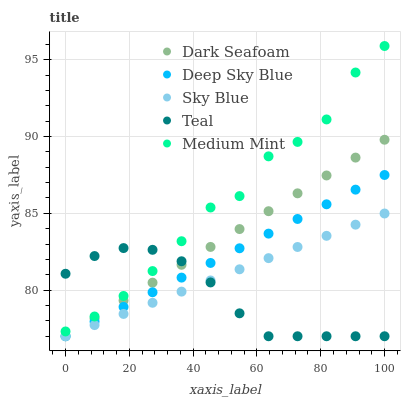Does Teal have the minimum area under the curve?
Answer yes or no. Yes. Does Medium Mint have the maximum area under the curve?
Answer yes or no. Yes. Does Sky Blue have the minimum area under the curve?
Answer yes or no. No. Does Sky Blue have the maximum area under the curve?
Answer yes or no. No. Is Deep Sky Blue the smoothest?
Answer yes or no. Yes. Is Medium Mint the roughest?
Answer yes or no. Yes. Is Sky Blue the smoothest?
Answer yes or no. No. Is Sky Blue the roughest?
Answer yes or no. No. Does Sky Blue have the lowest value?
Answer yes or no. Yes. Does Medium Mint have the highest value?
Answer yes or no. Yes. Does Sky Blue have the highest value?
Answer yes or no. No. Is Dark Seafoam less than Medium Mint?
Answer yes or no. Yes. Is Medium Mint greater than Dark Seafoam?
Answer yes or no. Yes. Does Dark Seafoam intersect Sky Blue?
Answer yes or no. Yes. Is Dark Seafoam less than Sky Blue?
Answer yes or no. No. Is Dark Seafoam greater than Sky Blue?
Answer yes or no. No. Does Dark Seafoam intersect Medium Mint?
Answer yes or no. No. 